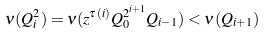<formula> <loc_0><loc_0><loc_500><loc_500>\nu ( Q _ { i } ^ { 2 } ) = \nu ( z ^ { \tau ( i ) } Q _ { 0 } ^ { 2 ^ { i + 1 } } Q _ { i - 1 } ) < \nu ( Q _ { i + 1 } )</formula> 